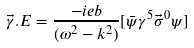Convert formula to latex. <formula><loc_0><loc_0><loc_500><loc_500>\vec { \gamma } . E = \frac { - i e b } { ( { \omega } ^ { 2 } - k ^ { 2 } ) } [ \bar { \psi } { \gamma } ^ { 5 } { \vec { \sigma } } ^ { 0 } { \psi } ]</formula> 